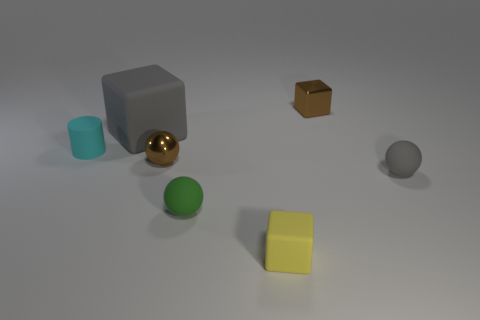What is the shape of the small metallic object to the left of the small rubber object in front of the small green object?
Your answer should be compact. Sphere. The large cube that is made of the same material as the tiny yellow object is what color?
Provide a short and direct response. Gray. Do the shiny cube and the large rubber block have the same color?
Give a very brief answer. No. There is a green object that is the same size as the brown ball; what is its shape?
Make the answer very short. Sphere. What size is the brown sphere?
Keep it short and to the point. Small. There is a rubber sphere that is on the right side of the brown metallic block; does it have the same size as the brown shiny thing that is on the left side of the yellow cube?
Provide a succinct answer. Yes. There is a shiny object behind the gray cube that is behind the tiny green thing; what color is it?
Give a very brief answer. Brown. What is the material of the gray thing that is the same size as the green sphere?
Give a very brief answer. Rubber. How many metallic objects are green objects or small brown things?
Your answer should be very brief. 2. What color is the small thing that is both right of the yellow matte cube and in front of the big object?
Provide a succinct answer. Gray. 